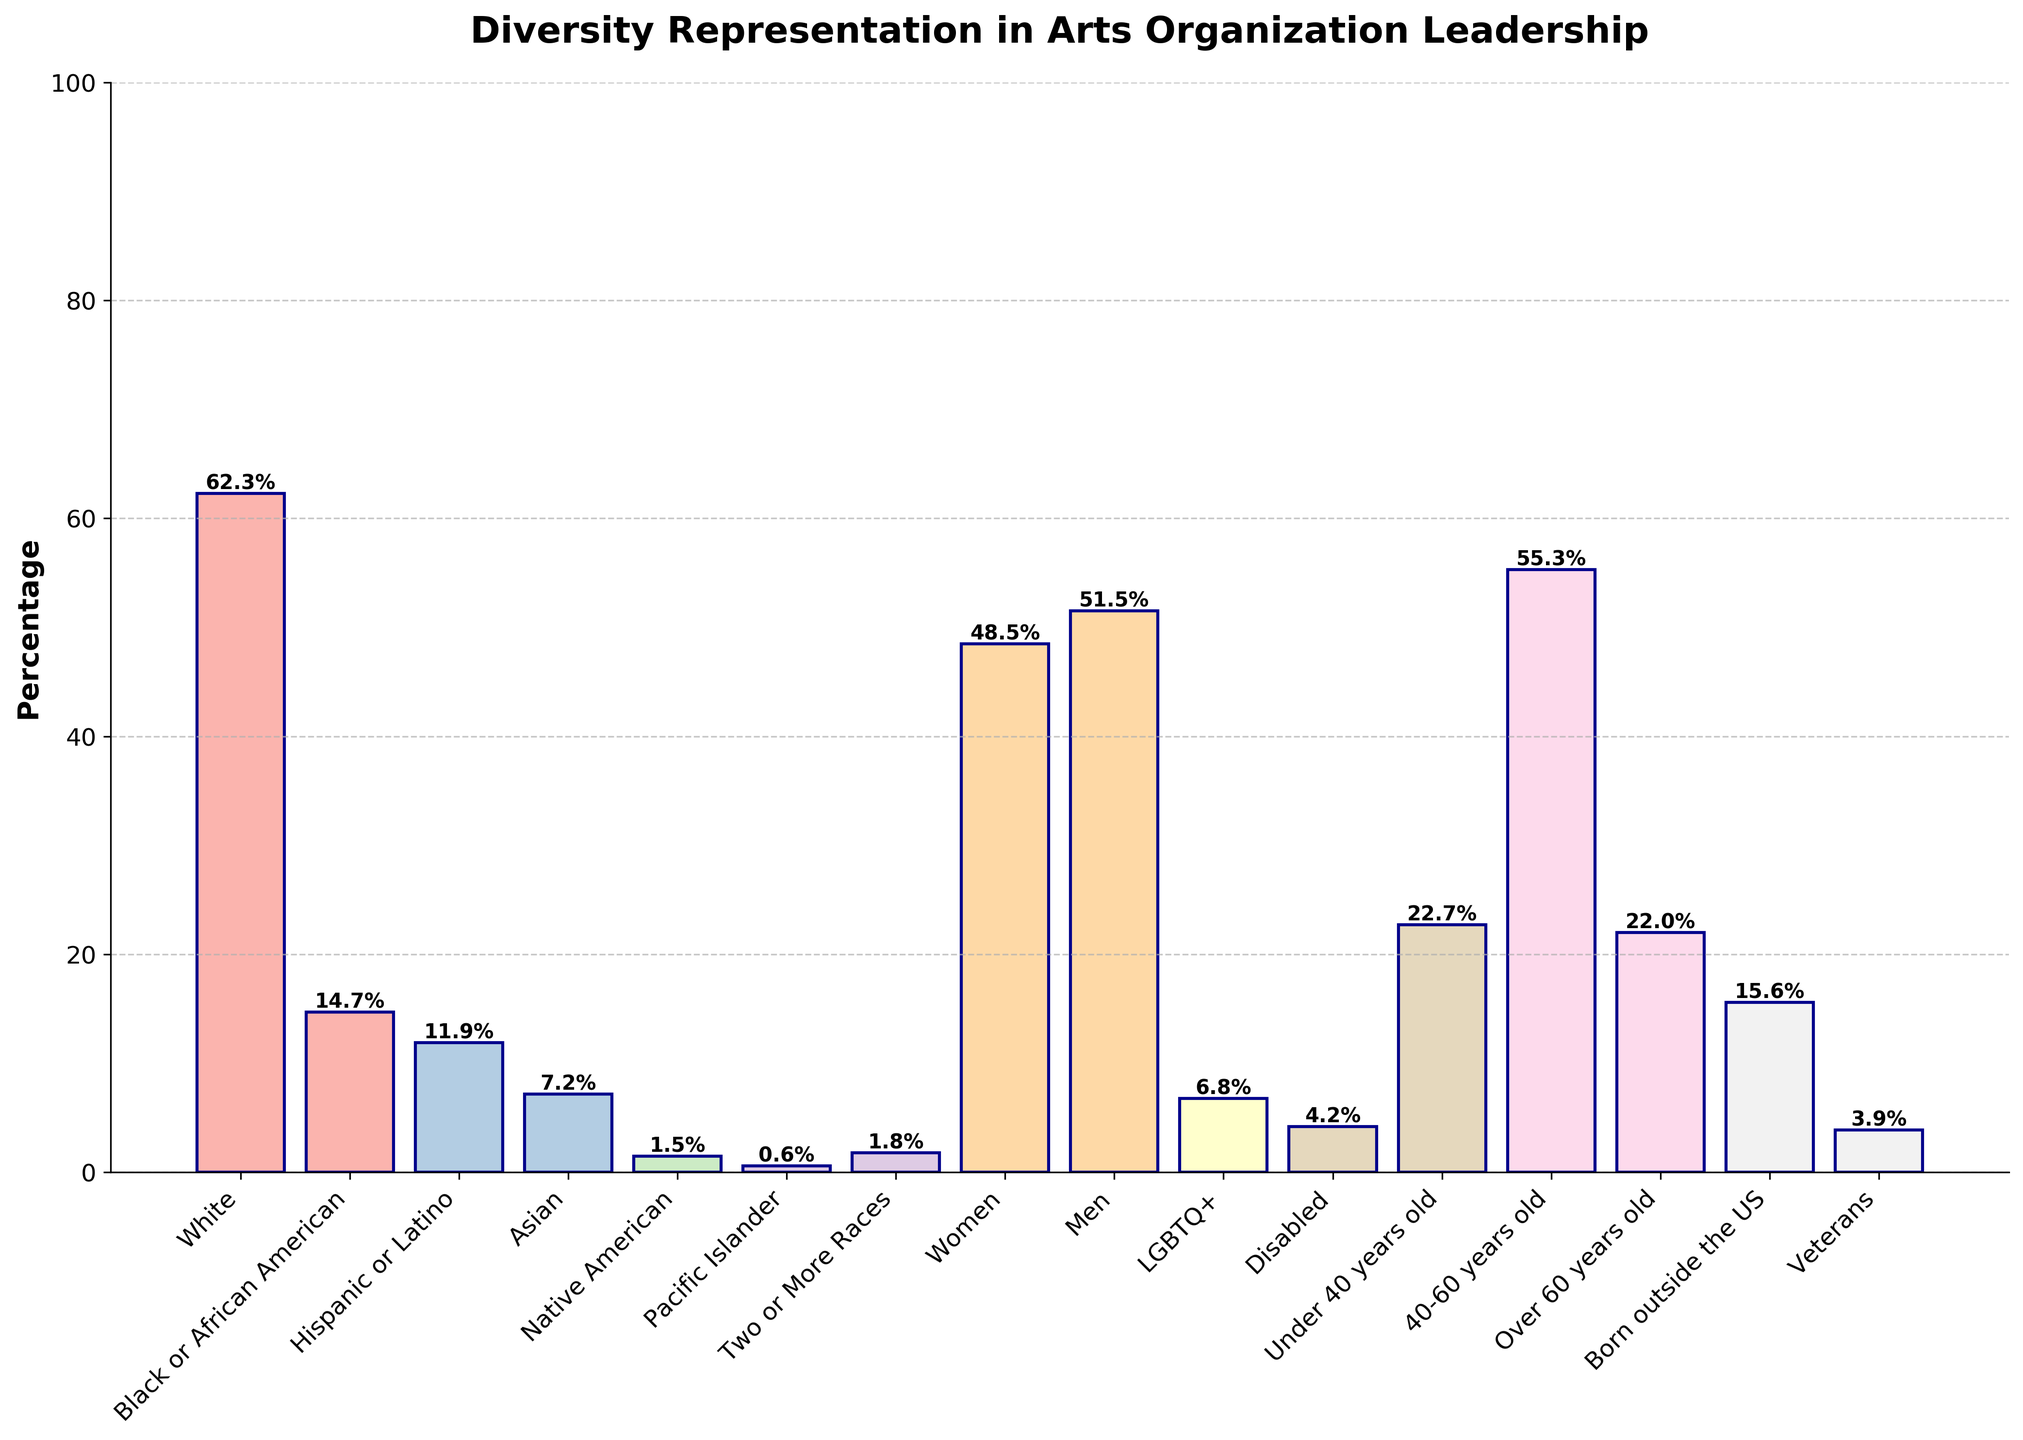What demographic has the highest percentage representation in leadership roles? The demographic with the highest percentage is determined by observing the tallest bar in the chart. The bar labeled 'White' is the tallest with a height of 62.3%.
Answer: White How many demographics have a representation of less than 5%? Count all the bars with heights below the 5% mark. These bars are 'Pacific Islander', 'Disabled', and 'Veterans', each with less than 5%.
Answer: 3 What is the combined percentage of 'Under 40 years old' and 'Over 60 years old' demographics? Add the percentages corresponding to 'Under 40 years old' (22.7%) and 'Over 60 years old' (22.0%). The sum is 22.7% + 22.0% = 44.7%.
Answer: 44.7% Which two demographics have nearly the same percentage representation? Observe the bars with similar heights. 'Black or African American' and 'Born outside the US' have percentages of 14.7% and 15.6%, respectively, which are very close.
Answer: Black or African American and Born outside the US What is the difference in percentage between women and men in leadership roles? The percentage of women is 48.5% and the percentage of men is 51.5%. Subtract the smaller percentage from the larger one: 51.5% - 48.5% = 3%.
Answer: 3% Is the percentage of LGBTQ+ representation higher than that of Disabled representation? Compare the heights of the bars for 'LGBTQ+' and 'Disabled'. 'LGBTQ+' has a percentage of 6.8% while 'Disabled' has 4.2%. Therefore, 6.8% is higher.
Answer: Yes What is the average percentage representation of under-represented racial groups (excluding 'White')? Calculate the average by summing the percentages for 'Black or African American' (14.7%), 'Hispanic or Latino' (11.9%), 'Asian' (7.2%), 'Native American' (1.5%), 'Pacific Islander' (0.6%), and 'Two or More Races' (1.8%), and then divide by the number of groups (6). (14.7 + 11.9 + 7.2 + 1.5 + 0.6 + 1.8) / 6 = 37.7 / 6 = 6.28%.
Answer: 6.3% Are women or people born outside the US more represented in leadership roles? Compare the heights of the bars for 'Women' and 'Born outside the US'. 'Women' has a percentage of 48.5% and 'Born outside the US' has 15.6%. 48.5% is greater.
Answer: Women Which demographic has the least representation in leadership roles? The demographic with the shortest bar represents the least percentage. The bar labeled 'Pacific Islander' is the shortest with 0.6%.
Answer: Pacific Islander Do any demographics have representations with percentages between 10% and 20%? Look for bars with heights within the range of 10% to 20%. Bars labeled 'Black or African American' (14.7%), 'Hispanic or Latino' (11.9%), and 'Born outside the US' (15.6%) fall within this range.
Answer: Yes 